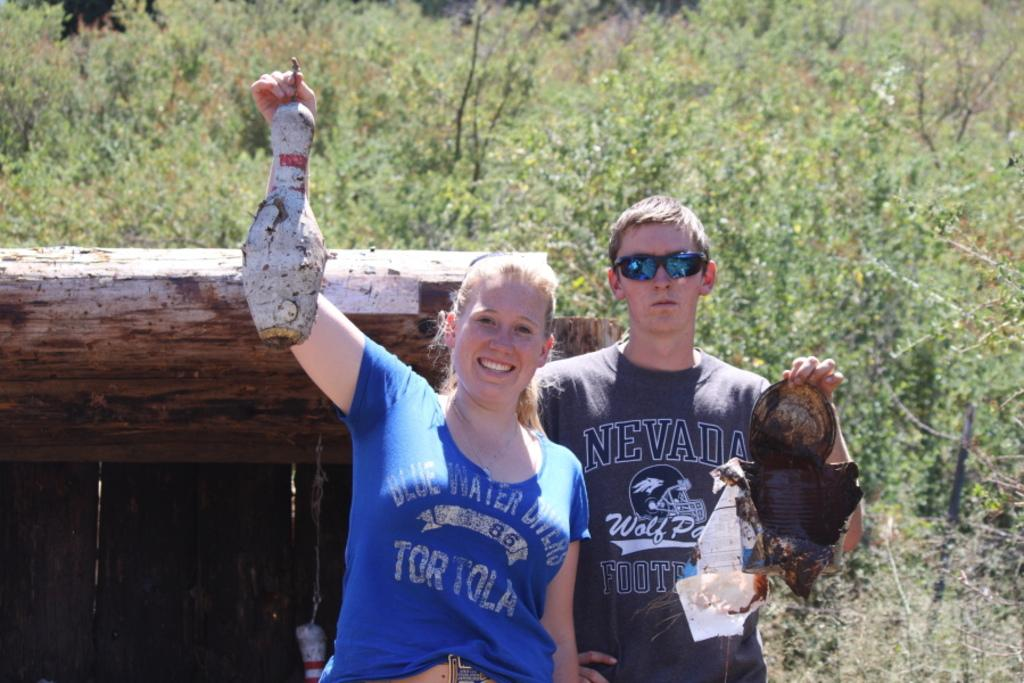How many people are present in the image? There are two people, a man and a woman, present in the image. What are the man and woman doing in the image? The man and woman are standing in the image. What are the man and woman holding in the image? The man and woman are holding objects in the image. What can be seen in the background of the image? There are green color plants in the background of the image. Can you see any rabbits in the image? No, there are no rabbits present in the image. Are the man and woman kissing in the image? The provided facts do not mention any kissing in the image. 